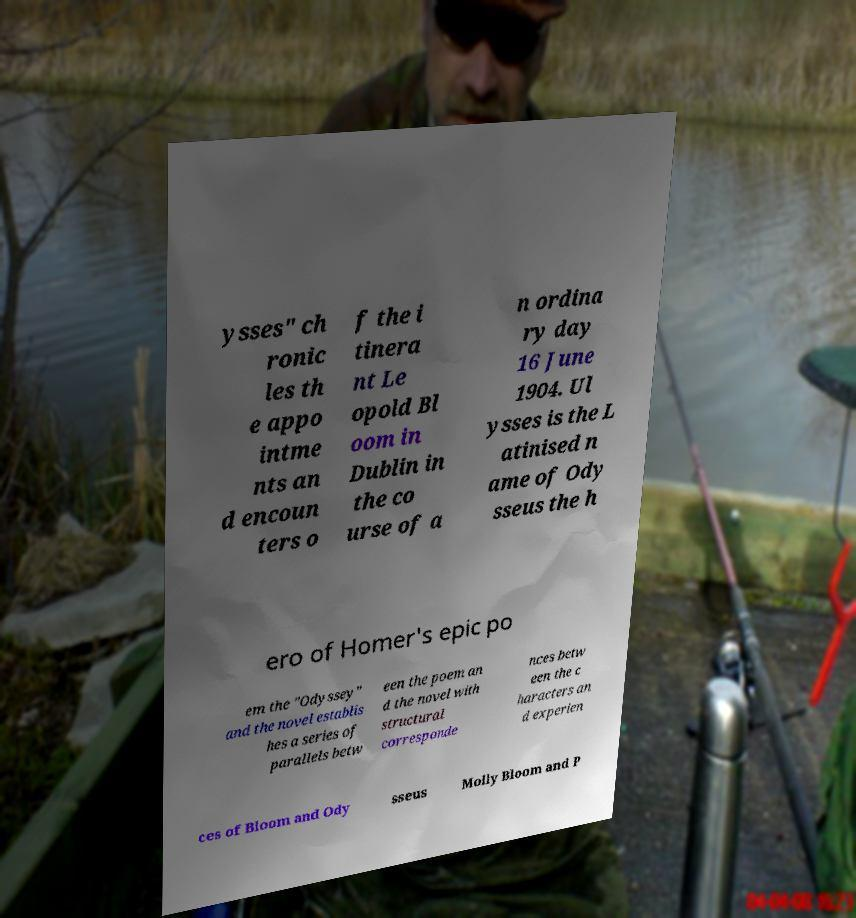Please read and relay the text visible in this image. What does it say? ysses" ch ronic les th e appo intme nts an d encoun ters o f the i tinera nt Le opold Bl oom in Dublin in the co urse of a n ordina ry day 16 June 1904. Ul ysses is the L atinised n ame of Ody sseus the h ero of Homer's epic po em the "Odyssey" and the novel establis hes a series of parallels betw een the poem an d the novel with structural corresponde nces betw een the c haracters an d experien ces of Bloom and Ody sseus Molly Bloom and P 